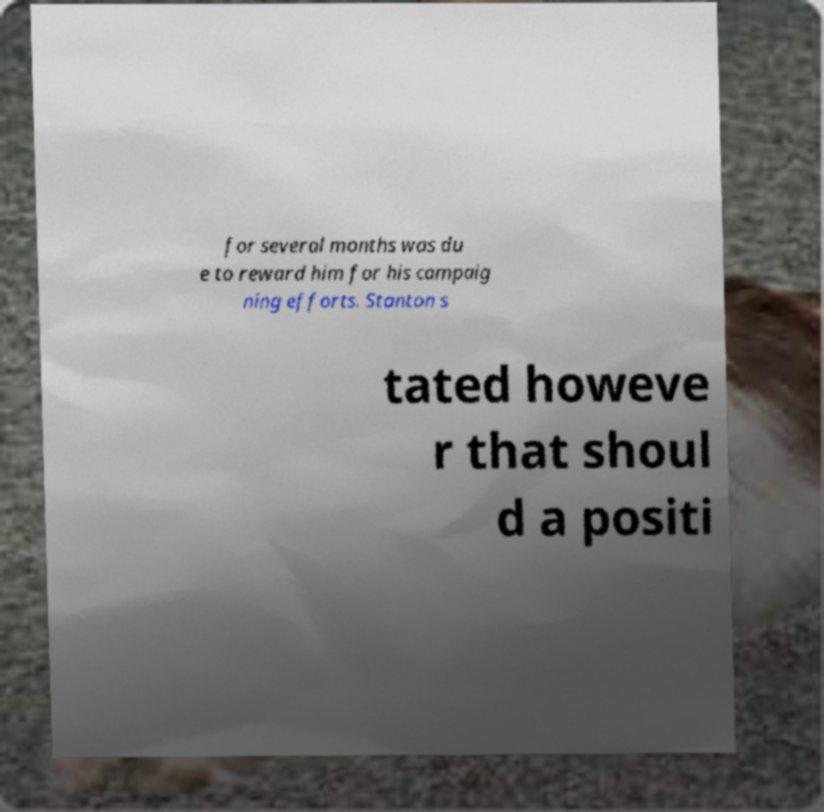What messages or text are displayed in this image? I need them in a readable, typed format. for several months was du e to reward him for his campaig ning efforts. Stanton s tated howeve r that shoul d a positi 